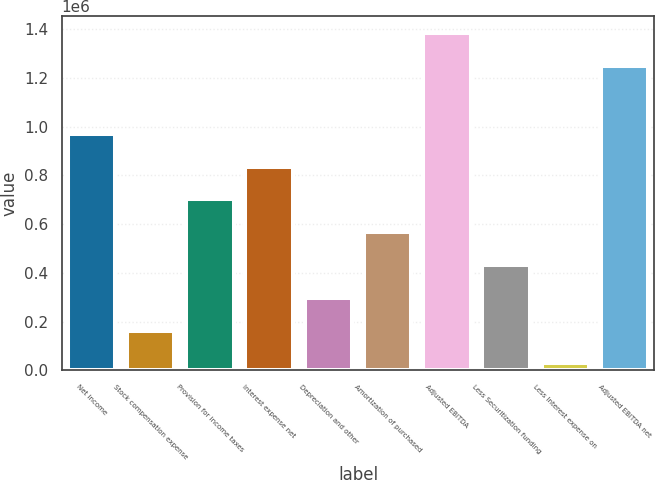Convert chart. <chart><loc_0><loc_0><loc_500><loc_500><bar_chart><fcel>Net income<fcel>Stock compensation expense<fcel>Provision for income taxes<fcel>Interest expense net<fcel>Depreciation and other<fcel>Amortization of purchased<fcel>Adjusted EBITDA<fcel>Less Securitization funding<fcel>Less Interest expense on<fcel>Adjusted EBITDA net<nl><fcel>970683<fcel>163621<fcel>701662<fcel>836173<fcel>298132<fcel>567152<fcel>1.38429e+06<fcel>432642<fcel>29111<fcel>1.24978e+06<nl></chart> 